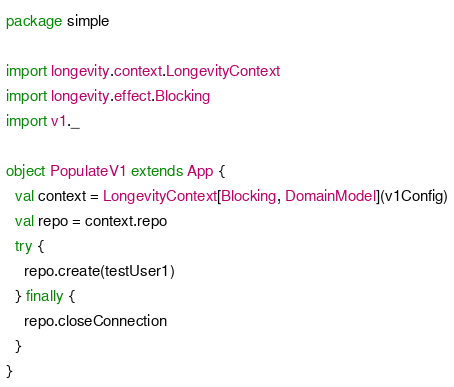<code> <loc_0><loc_0><loc_500><loc_500><_Scala_>package simple

import longevity.context.LongevityContext
import longevity.effect.Blocking
import v1._

object PopulateV1 extends App {
  val context = LongevityContext[Blocking, DomainModel](v1Config)
  val repo = context.repo
  try {
    repo.create(testUser1)
  } finally {
    repo.closeConnection
  }
}
</code> 